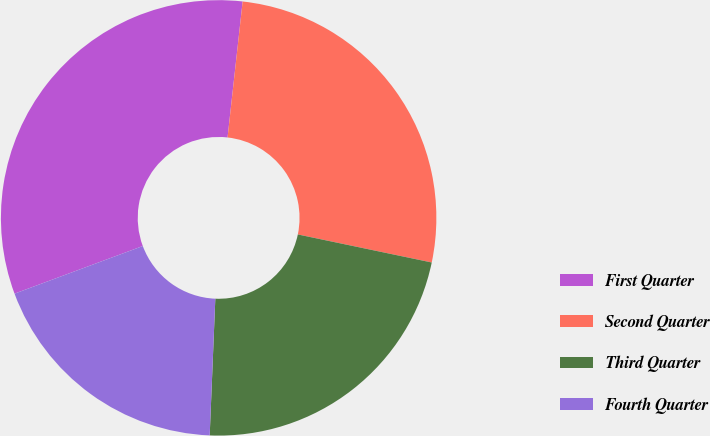Convert chart to OTSL. <chart><loc_0><loc_0><loc_500><loc_500><pie_chart><fcel>First Quarter<fcel>Second Quarter<fcel>Third Quarter<fcel>Fourth Quarter<nl><fcel>32.42%<fcel>26.53%<fcel>22.37%<fcel>18.69%<nl></chart> 